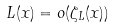<formula> <loc_0><loc_0><loc_500><loc_500>L ( x ) = o ( \zeta _ { L } ( x ) )</formula> 